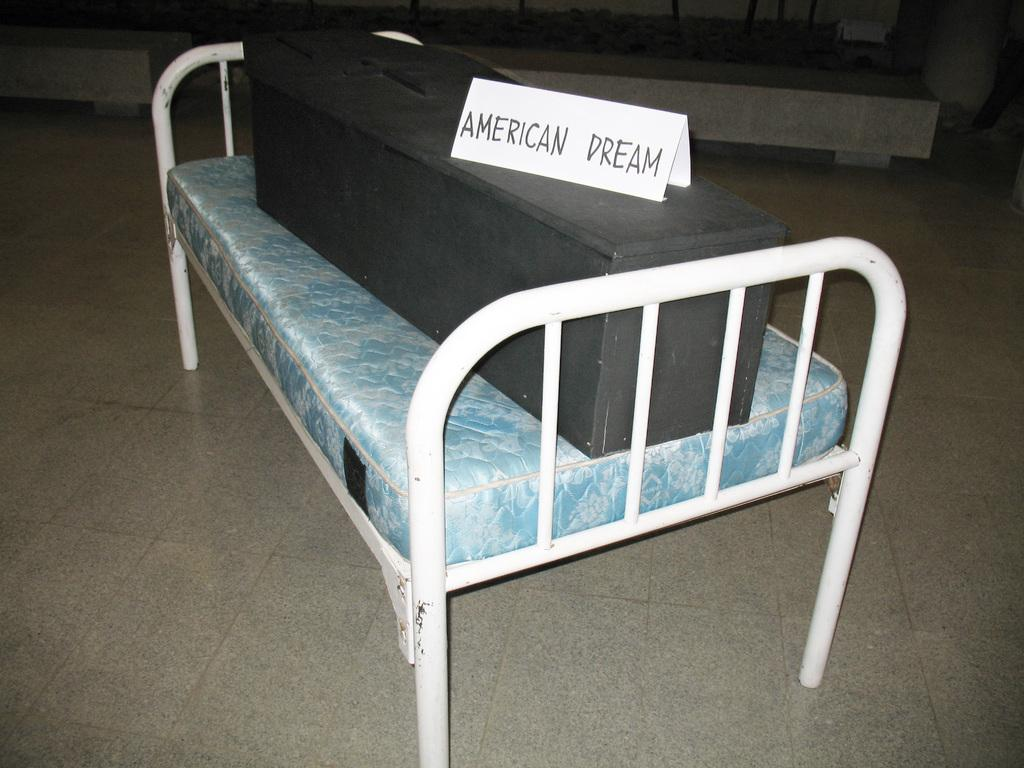What object is located on the bed in the image? There is a box on the bed in the image. Where is the box placed in relation to the bed? The box is on the bed. What is the position of the bed in the image? The bed is on the floor. What is placed on top of the box in the image? There is a paper on the box. What can be observed on the paper that is on the box? There is text written on the paper. How does the fish feel about the comfort of the bed in the image? There is no fish present in the image, so it is not possible to determine how a fish might feel about the comfort of the bed. 